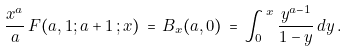Convert formula to latex. <formula><loc_0><loc_0><loc_500><loc_500>\frac { x ^ { a } } { a } \, F ( a , 1 ; a + 1 \, ; x ) \, = \, B _ { x } ( a , 0 ) \, = \, \int _ { 0 } ^ { \, x } \frac { y ^ { a - 1 } } { 1 - y } \, d y \, .</formula> 